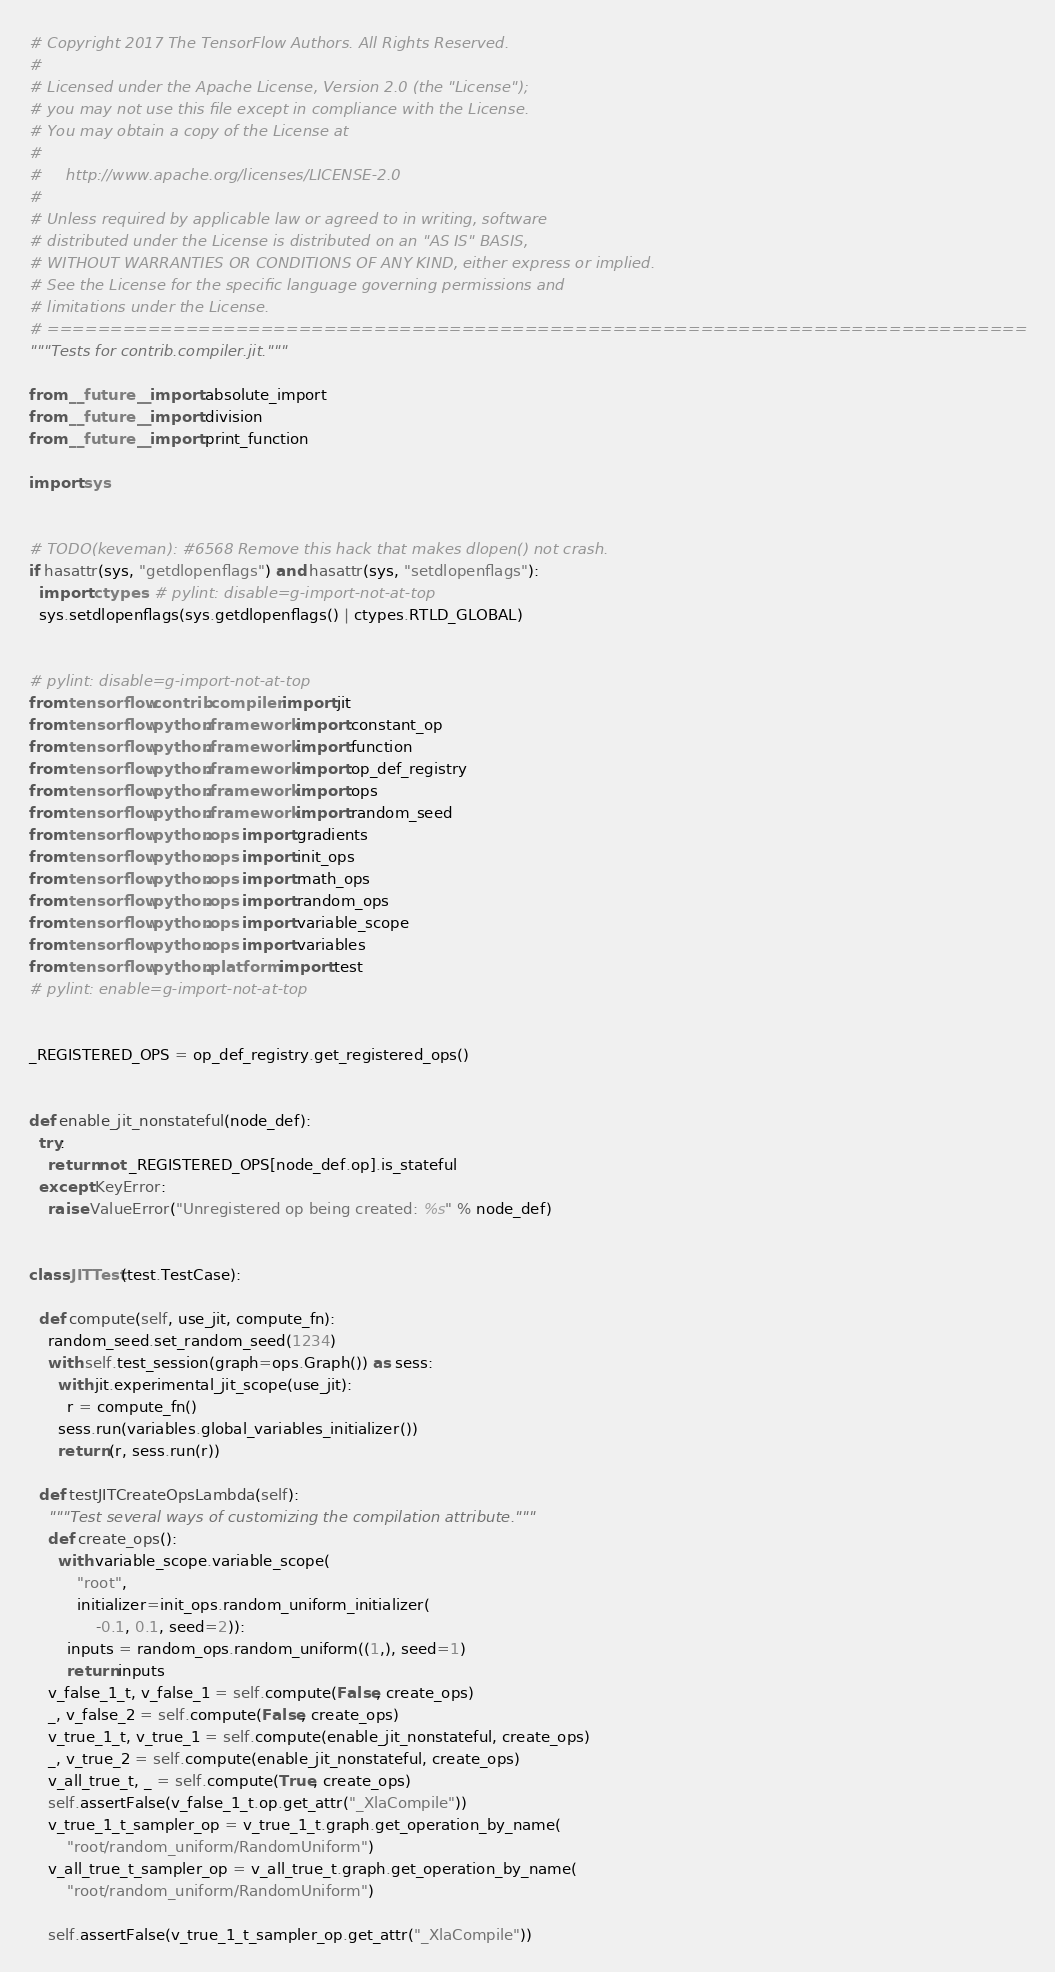Convert code to text. <code><loc_0><loc_0><loc_500><loc_500><_Python_># Copyright 2017 The TensorFlow Authors. All Rights Reserved.
#
# Licensed under the Apache License, Version 2.0 (the "License");
# you may not use this file except in compliance with the License.
# You may obtain a copy of the License at
#
#     http://www.apache.org/licenses/LICENSE-2.0
#
# Unless required by applicable law or agreed to in writing, software
# distributed under the License is distributed on an "AS IS" BASIS,
# WITHOUT WARRANTIES OR CONDITIONS OF ANY KIND, either express or implied.
# See the License for the specific language governing permissions and
# limitations under the License.
# ==============================================================================
"""Tests for contrib.compiler.jit."""

from __future__ import absolute_import
from __future__ import division
from __future__ import print_function

import sys


# TODO(keveman): #6568 Remove this hack that makes dlopen() not crash.
if hasattr(sys, "getdlopenflags") and hasattr(sys, "setdlopenflags"):
  import ctypes  # pylint: disable=g-import-not-at-top
  sys.setdlopenflags(sys.getdlopenflags() | ctypes.RTLD_GLOBAL)


# pylint: disable=g-import-not-at-top
from tensorflow.contrib.compiler import jit
from tensorflow.python.framework import constant_op
from tensorflow.python.framework import function
from tensorflow.python.framework import op_def_registry
from tensorflow.python.framework import ops
from tensorflow.python.framework import random_seed
from tensorflow.python.ops import gradients
from tensorflow.python.ops import init_ops
from tensorflow.python.ops import math_ops
from tensorflow.python.ops import random_ops
from tensorflow.python.ops import variable_scope
from tensorflow.python.ops import variables
from tensorflow.python.platform import test
# pylint: enable=g-import-not-at-top


_REGISTERED_OPS = op_def_registry.get_registered_ops()


def enable_jit_nonstateful(node_def):
  try:
    return not _REGISTERED_OPS[node_def.op].is_stateful
  except KeyError:
    raise ValueError("Unregistered op being created: %s" % node_def)


class JITTest(test.TestCase):

  def compute(self, use_jit, compute_fn):
    random_seed.set_random_seed(1234)
    with self.test_session(graph=ops.Graph()) as sess:
      with jit.experimental_jit_scope(use_jit):
        r = compute_fn()
      sess.run(variables.global_variables_initializer())
      return (r, sess.run(r))

  def testJITCreateOpsLambda(self):
    """Test several ways of customizing the compilation attribute."""
    def create_ops():
      with variable_scope.variable_scope(
          "root",
          initializer=init_ops.random_uniform_initializer(
              -0.1, 0.1, seed=2)):
        inputs = random_ops.random_uniform((1,), seed=1)
        return inputs
    v_false_1_t, v_false_1 = self.compute(False, create_ops)
    _, v_false_2 = self.compute(False, create_ops)
    v_true_1_t, v_true_1 = self.compute(enable_jit_nonstateful, create_ops)
    _, v_true_2 = self.compute(enable_jit_nonstateful, create_ops)
    v_all_true_t, _ = self.compute(True, create_ops)
    self.assertFalse(v_false_1_t.op.get_attr("_XlaCompile"))
    v_true_1_t_sampler_op = v_true_1_t.graph.get_operation_by_name(
        "root/random_uniform/RandomUniform")
    v_all_true_t_sampler_op = v_all_true_t.graph.get_operation_by_name(
        "root/random_uniform/RandomUniform")

    self.assertFalse(v_true_1_t_sampler_op.get_attr("_XlaCompile"))</code> 